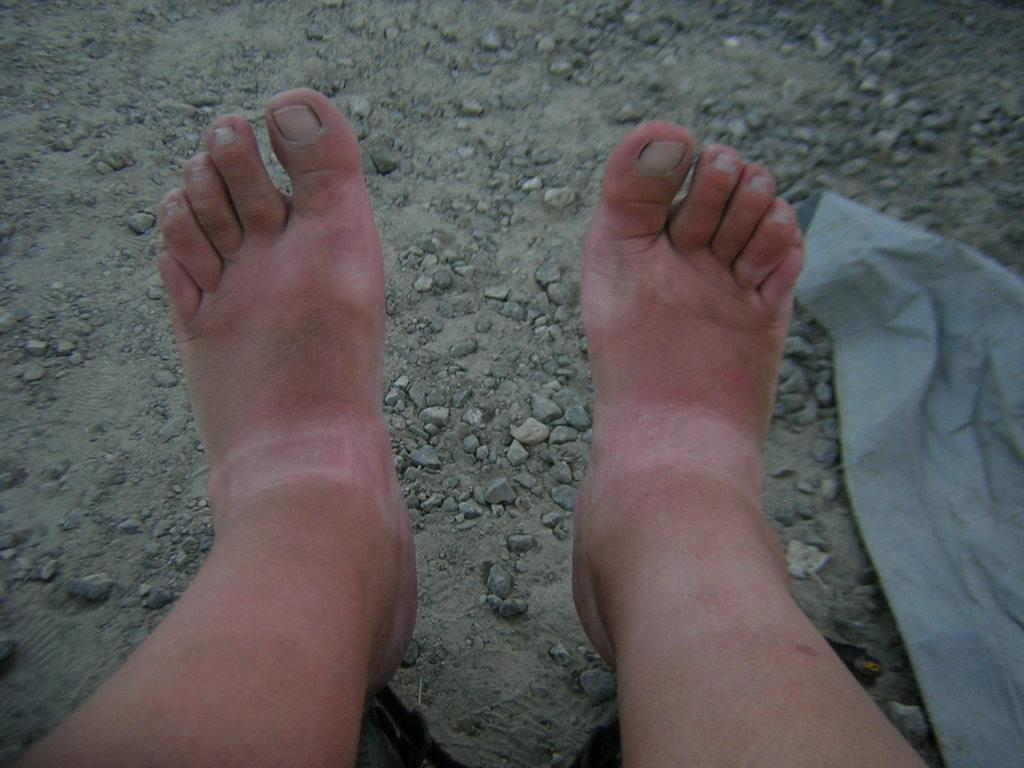What body part is visible in the image? There are a person's legs in the image. What type of material is present in the image? There is a white cloth in the image. What natural elements can be seen in the image? There are stones and sand visible in the image. How many boys are reciting a verse together in the image? There are no boys or verses present in the image. 